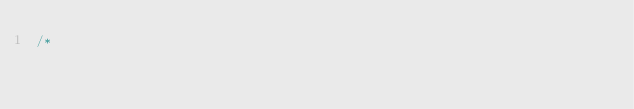<code> <loc_0><loc_0><loc_500><loc_500><_Java_>/*</code> 